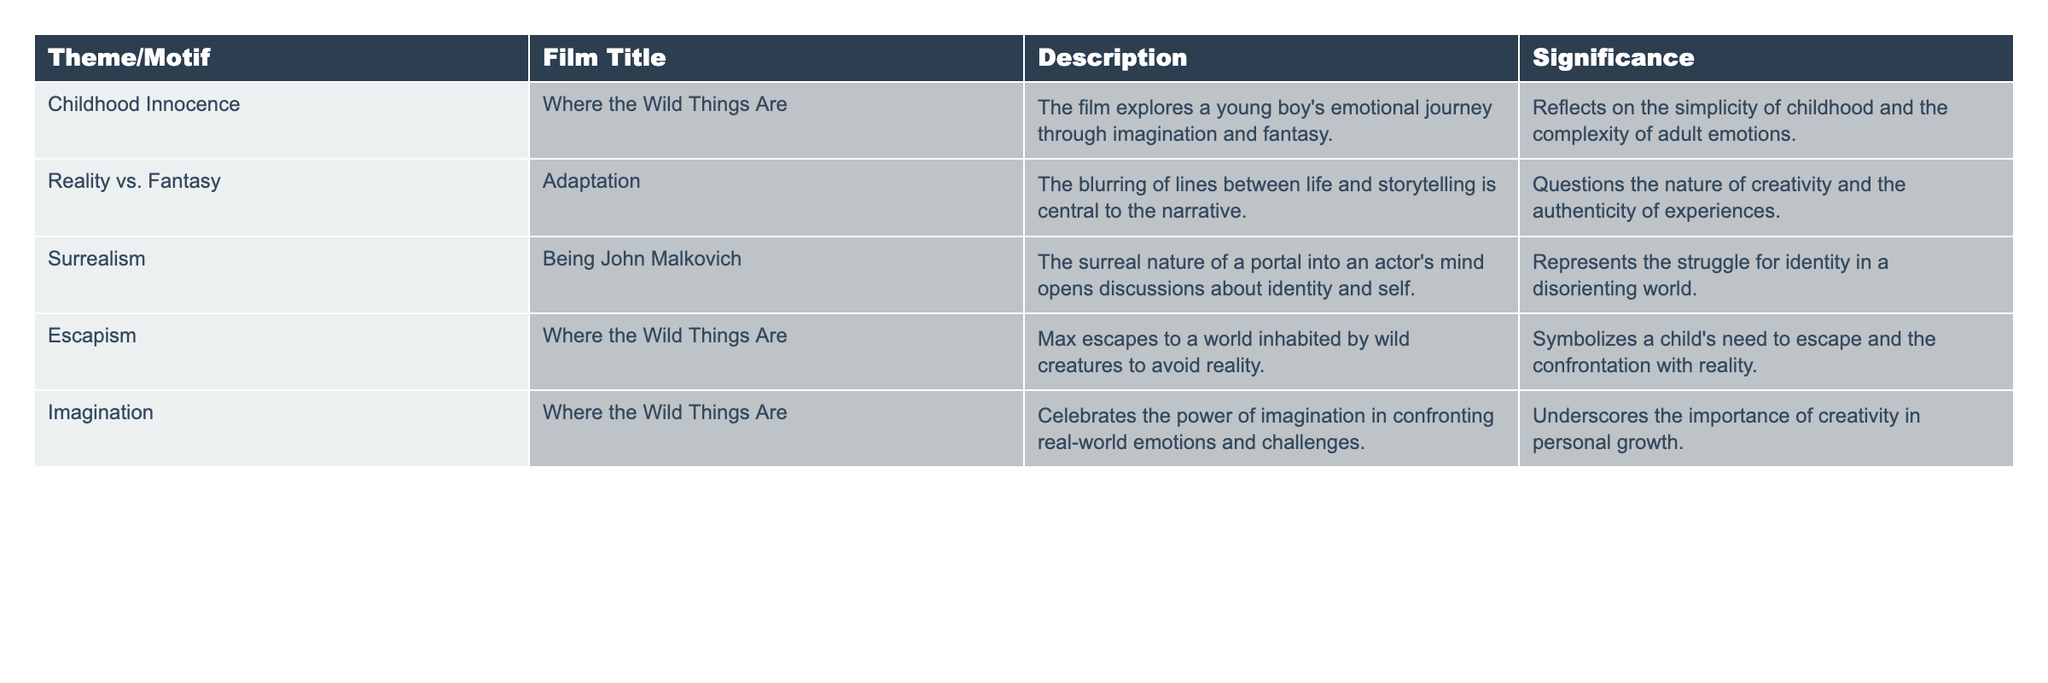What film explores the theme of childhood innocence? The table lists "Where the Wild Things Are" under the theme of childhood innocence, indicating it is the film that explores this theme.
Answer: Where the Wild Things Are How many films feature the theme of escapism? The table shows that "Where the Wild Things Are" is the only film associated with the theme of escapism. Therefore, there is 1 film.
Answer: 1 Is surrealism a theme in "Adaptation"? The table indicates that surrealism is associated with "Being John Malkovich," not "Adaptation," so the answer is no.
Answer: No Which theme is most frequently represented in the films listed? By reviewing the table, "Where the Wild Things Are" appears three times, while no other film appears more than once. Therefore, childhood innocence, escapism, and imagination are the most represented themes.
Answer: Childhood Innocence, Escapism, Imagination Can you list all the films that deal with the concept of reality versus fantasy? The table specifies that only "Adaptation" is linked to the theme of reality versus fantasy. Hence, the list contains just one film.
Answer: Adaptation Which film incorporates both the themes of childhood innocence and imagination? The table shows that "Where the Wild Things Are" encompasses both themes, confirming its dual representation.
Answer: Where the Wild Things Are Are there any films that explore more than one theme? "Where the Wild Things Are" addresses multiple themes: childhood innocence, escapism, and imagination. Therefore, yes, there are films that explore more than one theme.
Answer: Yes What is the significance of the theme of imagination in "Where the Wild Things Are"? The table describes that the theme of imagination in this film underscores the importance of creativity in personal growth.
Answer: Importance of creativity in personal growth 